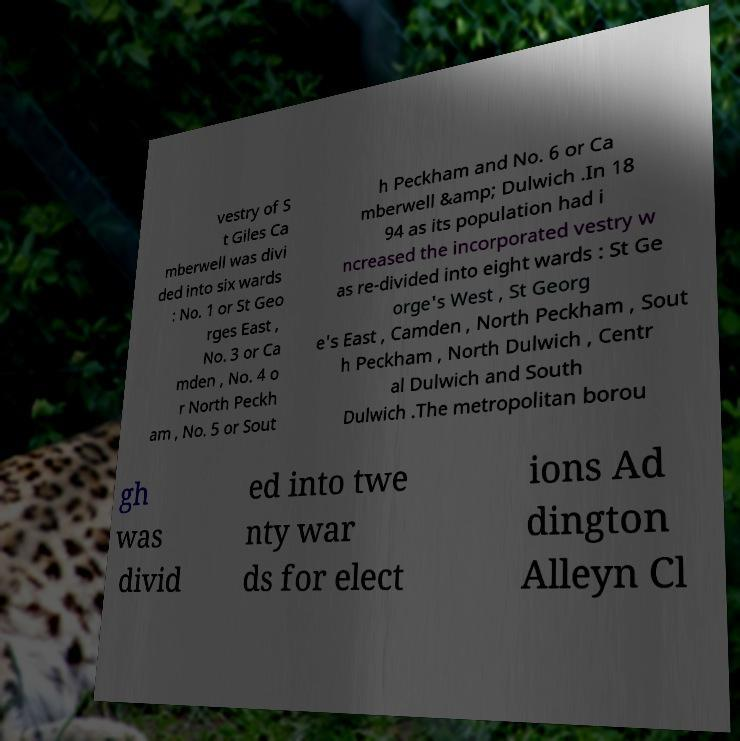Please read and relay the text visible in this image. What does it say? vestry of S t Giles Ca mberwell was divi ded into six wards : No. 1 or St Geo rges East , No. 3 or Ca mden , No. 4 o r North Peckh am , No. 5 or Sout h Peckham and No. 6 or Ca mberwell &amp; Dulwich .In 18 94 as its population had i ncreased the incorporated vestry w as re-divided into eight wards : St Ge orge's West , St Georg e's East , Camden , North Peckham , Sout h Peckham , North Dulwich , Centr al Dulwich and South Dulwich .The metropolitan borou gh was divid ed into twe nty war ds for elect ions Ad dington Alleyn Cl 